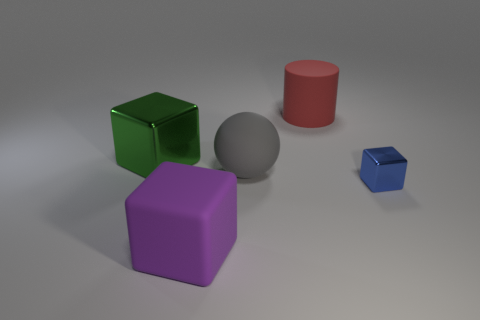Subtract all metallic cubes. How many cubes are left? 1 Subtract all green blocks. How many blocks are left? 2 Subtract 1 balls. How many balls are left? 0 Add 5 large gray things. How many objects exist? 10 Subtract all big red cylinders. Subtract all big gray rubber objects. How many objects are left? 3 Add 5 matte cylinders. How many matte cylinders are left? 6 Add 5 purple rubber things. How many purple rubber things exist? 6 Subtract 0 yellow cylinders. How many objects are left? 5 Subtract all balls. How many objects are left? 4 Subtract all cyan cylinders. Subtract all blue balls. How many cylinders are left? 1 